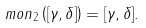<formula> <loc_0><loc_0><loc_500><loc_500>\ m o n _ { 2 } \left ( [ \gamma , \delta ] \right ) = [ \gamma , \delta ] .</formula> 